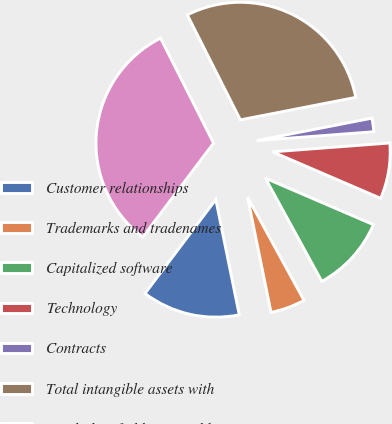Convert chart. <chart><loc_0><loc_0><loc_500><loc_500><pie_chart><fcel>Customer relationships<fcel>Trademarks and tradenames<fcel>Capitalized software<fcel>Technology<fcel>Contracts<fcel>Total intangible assets with<fcel>Total identifiable intangible<nl><fcel>13.48%<fcel>4.77%<fcel>10.57%<fcel>7.67%<fcel>1.86%<fcel>29.38%<fcel>32.28%<nl></chart> 